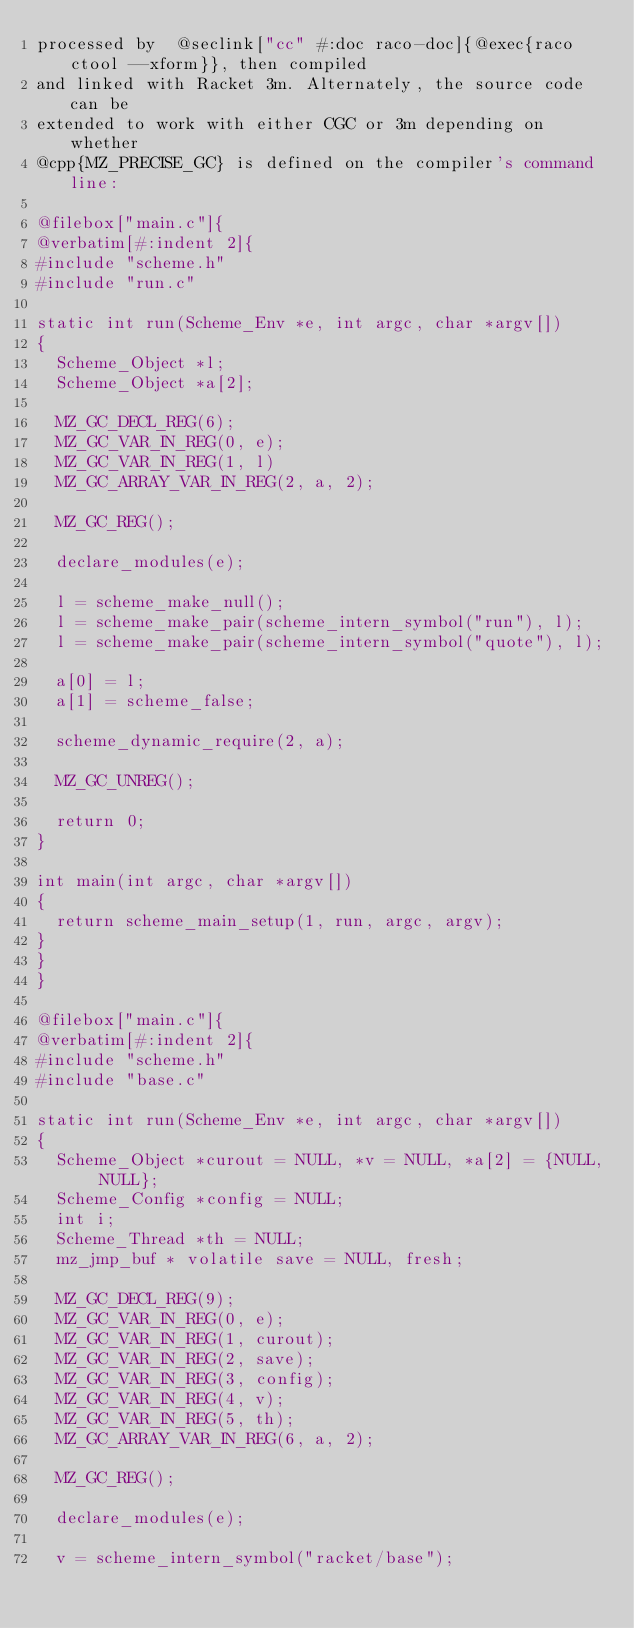<code> <loc_0><loc_0><loc_500><loc_500><_Racket_>processed by  @seclink["cc" #:doc raco-doc]{@exec{raco ctool --xform}}, then compiled
and linked with Racket 3m. Alternately, the source code can be
extended to work with either CGC or 3m depending on whether
@cpp{MZ_PRECISE_GC} is defined on the compiler's command line:

@filebox["main.c"]{
@verbatim[#:indent 2]{
#include "scheme.h"
#include "run.c"

static int run(Scheme_Env *e, int argc, char *argv[])
{
  Scheme_Object *l;
  Scheme_Object *a[2];

  MZ_GC_DECL_REG(6);
  MZ_GC_VAR_IN_REG(0, e);
  MZ_GC_VAR_IN_REG(1, l)
  MZ_GC_ARRAY_VAR_IN_REG(2, a, 2);

  MZ_GC_REG();

  declare_modules(e);

  l = scheme_make_null();
  l = scheme_make_pair(scheme_intern_symbol("run"), l);
  l = scheme_make_pair(scheme_intern_symbol("quote"), l);

  a[0] = l;
  a[1] = scheme_false;

  scheme_dynamic_require(2, a);

  MZ_GC_UNREG();

  return 0;
}

int main(int argc, char *argv[])
{
  return scheme_main_setup(1, run, argc, argv);
}
}
}

@filebox["main.c"]{
@verbatim[#:indent 2]{
#include "scheme.h"
#include "base.c"

static int run(Scheme_Env *e, int argc, char *argv[])
{
  Scheme_Object *curout = NULL, *v = NULL, *a[2] = {NULL, NULL};
  Scheme_Config *config = NULL;
  int i;
  Scheme_Thread *th = NULL;
  mz_jmp_buf * volatile save = NULL, fresh;

  MZ_GC_DECL_REG(9);
  MZ_GC_VAR_IN_REG(0, e);
  MZ_GC_VAR_IN_REG(1, curout);
  MZ_GC_VAR_IN_REG(2, save);
  MZ_GC_VAR_IN_REG(3, config);
  MZ_GC_VAR_IN_REG(4, v);
  MZ_GC_VAR_IN_REG(5, th);
  MZ_GC_ARRAY_VAR_IN_REG(6, a, 2);

  MZ_GC_REG();

  declare_modules(e);

  v = scheme_intern_symbol("racket/base");</code> 